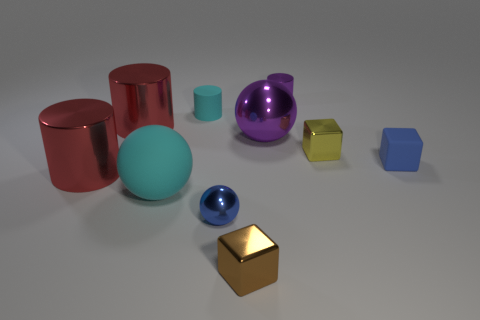Subtract all cyan cylinders. How many cylinders are left? 3 Subtract all purple cylinders. How many cylinders are left? 3 Subtract all gray cylinders. Subtract all gray blocks. How many cylinders are left? 4 Subtract all cubes. How many objects are left? 7 Add 1 small rubber cubes. How many small rubber cubes are left? 2 Add 3 small cyan matte cylinders. How many small cyan matte cylinders exist? 4 Subtract 0 cyan blocks. How many objects are left? 10 Subtract all tiny brown objects. Subtract all brown matte things. How many objects are left? 9 